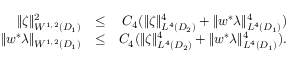Convert formula to latex. <formula><loc_0><loc_0><loc_500><loc_500>\begin{array} { r l r } { \| \zeta \| _ { W ^ { 1 , 2 } ( D _ { 1 } ) } ^ { 2 } } & { \leq } & { C _ { 4 } ( \| \zeta \| _ { L ^ { 4 } ( D _ { 2 } ) } ^ { 4 } + \| w ^ { * } \lambda \| _ { L ^ { 4 } ( D _ { 1 } ) } ^ { 4 } ) } \\ { \| w ^ { * } \lambda \| _ { W ^ { 1 , 2 } ( D _ { 1 } ) } } & { \leq } & { C _ { 4 } ( \| \zeta \| _ { L ^ { 4 } ( D _ { 2 } ) } ^ { 4 } + \| w ^ { * } \lambda \| _ { L ^ { 4 } ( D _ { 1 } ) } ^ { 4 } ) . } \end{array}</formula> 